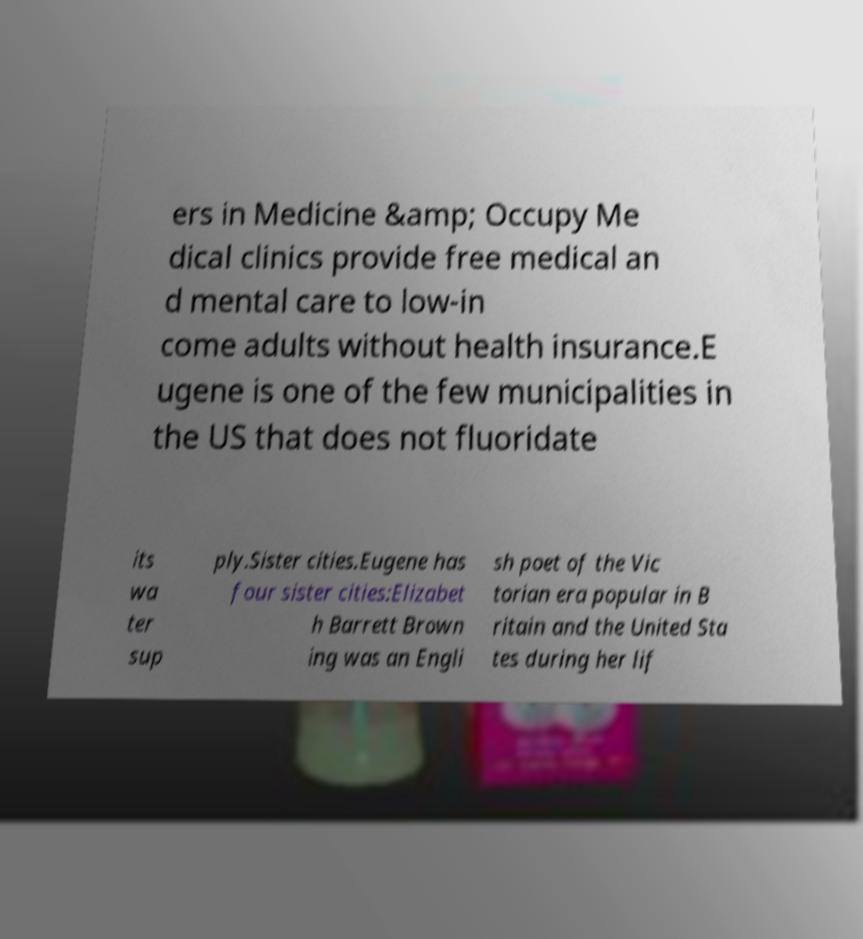Could you extract and type out the text from this image? ers in Medicine &amp; Occupy Me dical clinics provide free medical an d mental care to low-in come adults without health insurance.E ugene is one of the few municipalities in the US that does not fluoridate its wa ter sup ply.Sister cities.Eugene has four sister cities:Elizabet h Barrett Brown ing was an Engli sh poet of the Vic torian era popular in B ritain and the United Sta tes during her lif 